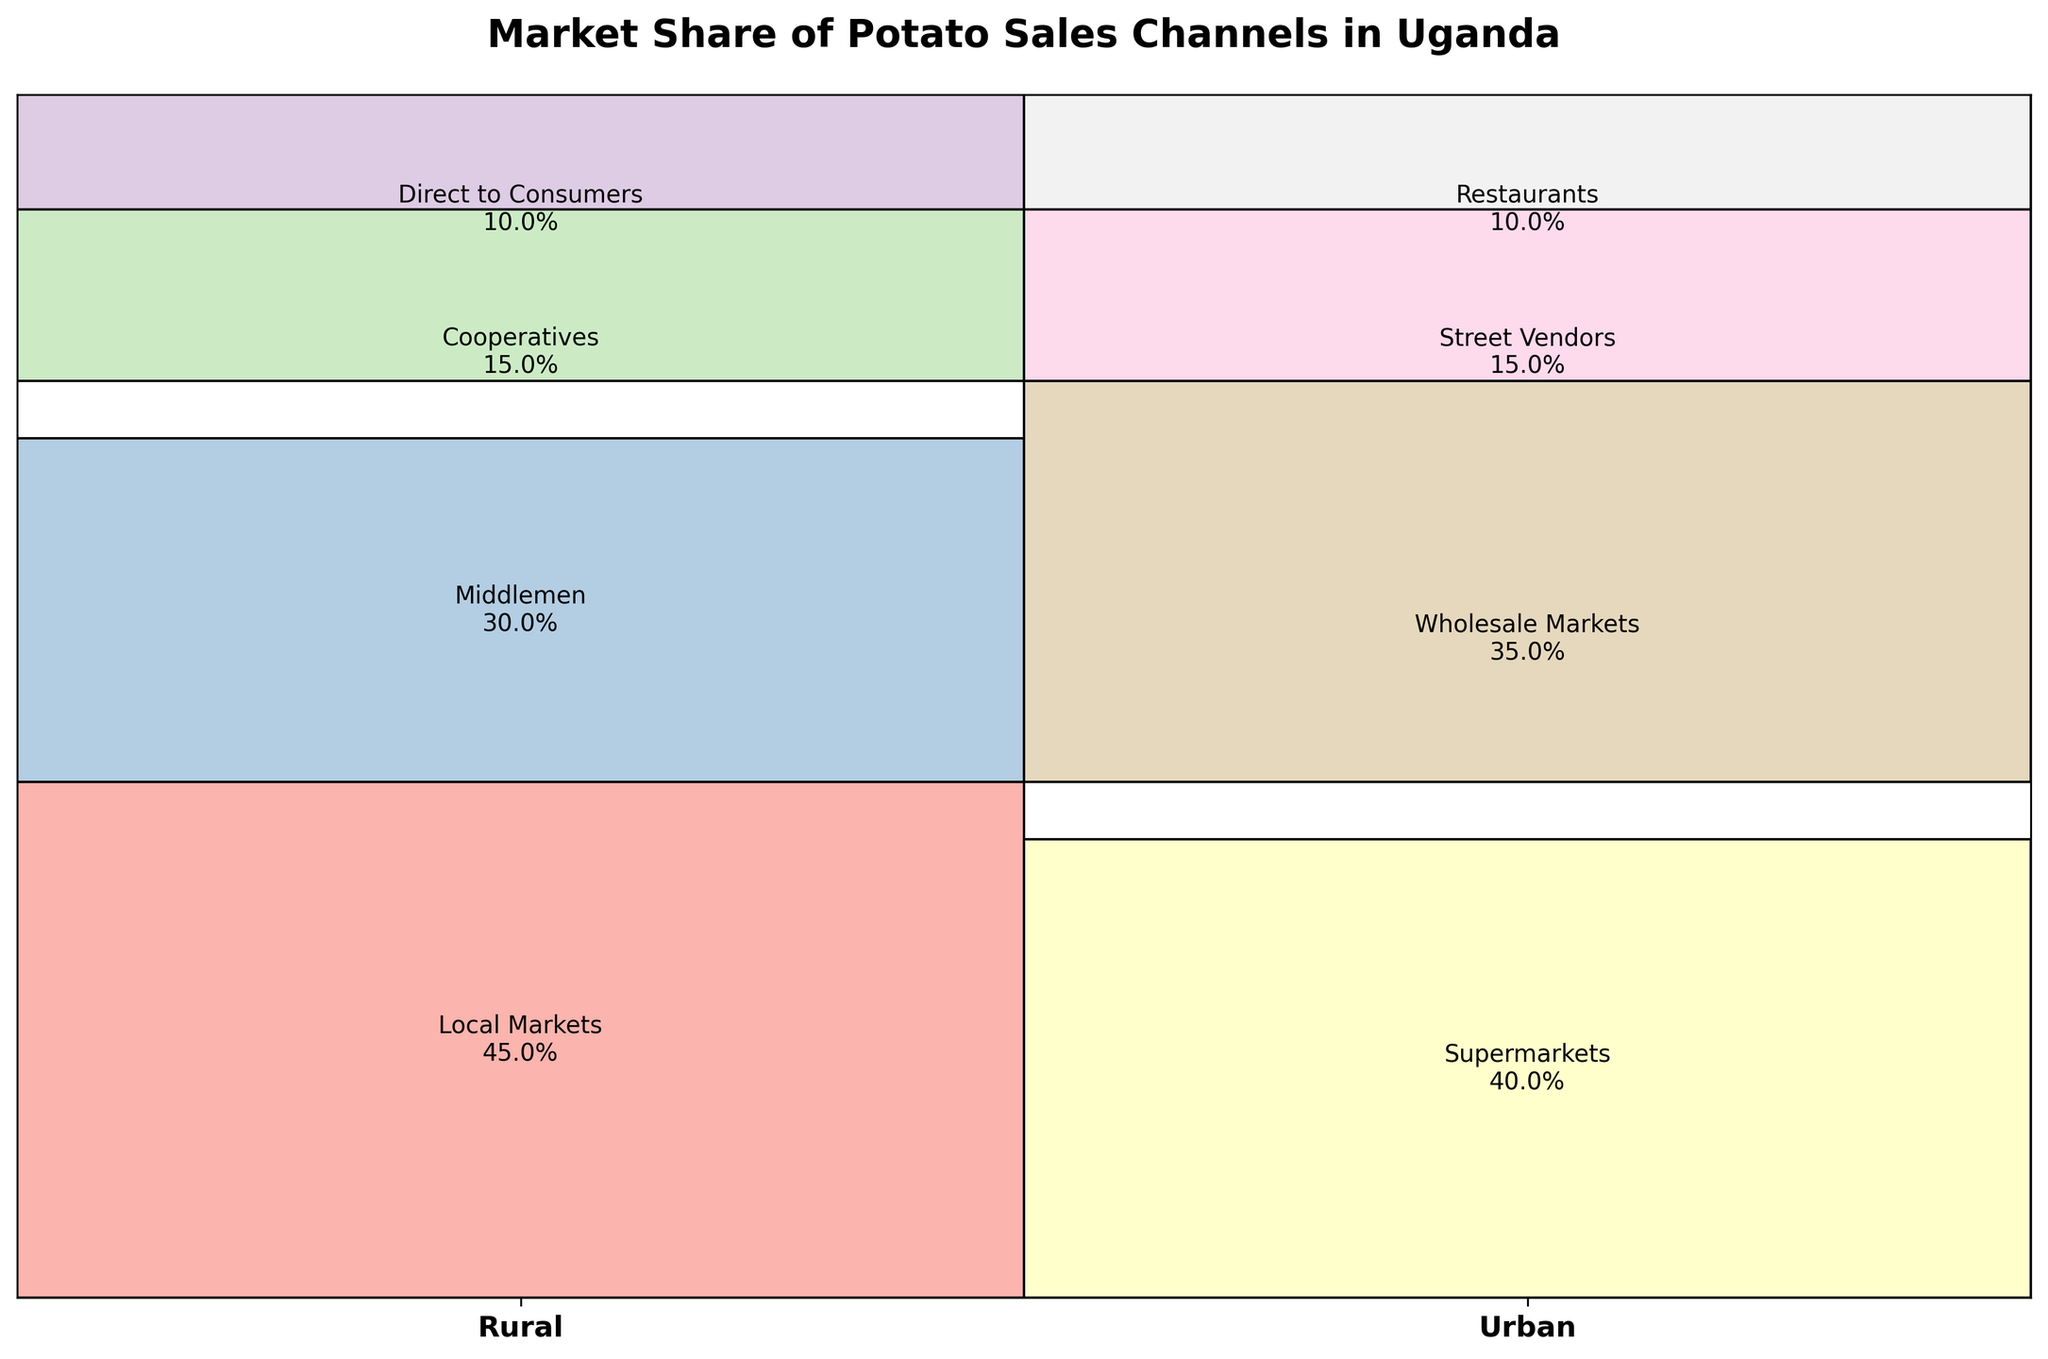What is the title of the mosaic plot? The title of a plot is usually found at the top and is a concise description of what the plot represents. In the mosaic plot provided in the task description, the title is "Market Share of Potato Sales Channels in Uganda".
Answer: Market Share of Potato Sales Channels in Uganda Which potato sales channel has the highest market share in rural areas? By examining the left side of the mosaic plot (Rural), we notice that the largest rectangle corresponds to the channel "Local Markets" with 45%.
Answer: Local Markets What are the four potato sales channels used in urban areas? To get this information, look at the right side of the mosaic plot (Urban). The text labels inside the rectangles list the sales channels as "Supermarkets," "Wholesale Markets," "Street Vendors," and "Restaurants."
Answer: Supermarkets, Wholesale Markets, Street Vendors, Restaurants How much market share does "Middlemen" have in rural areas compared to "Wholesale Markets" in urban areas? For this comparison, we need to look at both specified channels' respective sections in the mosaic plot. "Middlemen" in rural areas has 30%, while "Wholesale Markets" in urban areas has 35%. Therefore, "Wholesale Markets" has 5% more market share than "Middlemen".
Answer: 5% more What is the combined market share of "Cooperatives" and "Direct to Consumers" in rural areas? To find the combined market share, sum the individual percentages of "Cooperatives" and "Direct to Consumers" in rural areas. These are 15% and 10%, respectively. Adding these together results in a combined market share of 25%.
Answer: 25% Which sales channel has equal market share in both rural and urban areas? By examining the plot, we can see the percentages associated with each channel. The channel "Direct to Consumers" is only present in rural areas at 10%, while "Restaurants" in urban areas also has a market share of 10%, which is not a direct equality found. Thus, none of the channels has an exact identical percentage in both areas.
Answer: None Which area has a larger market share for "Street Vendors"? Firstly, identify the market share for "Street Vendors" in urban areas, which is 15%. The term "Street Vendors" does not appear in rural areas, indicating it does not have market share there. Hence, urban areas have a larger market share for this channel.
Answer: Urban In rural areas, how does the market share of "Local Markets" compare to the sum of "Cooperatives" and "Direct to Consumers"? The market share for "Local Markets" is 45%. The sum of "Cooperatives" and "Direct to Consumers" is 15% + 10% = 25%. 45% is greater than 25%.
Answer: 45% is greater What is the percentage difference between the largest and smallest market share channels in urban areas? To find this, identify the largest and smallest percentages in urban areas. The largest, "Supermarkets," is 40%, and the smallest, "Restaurants," is 10%. The difference is 40% - 10% = 30%.
Answer: 30% 